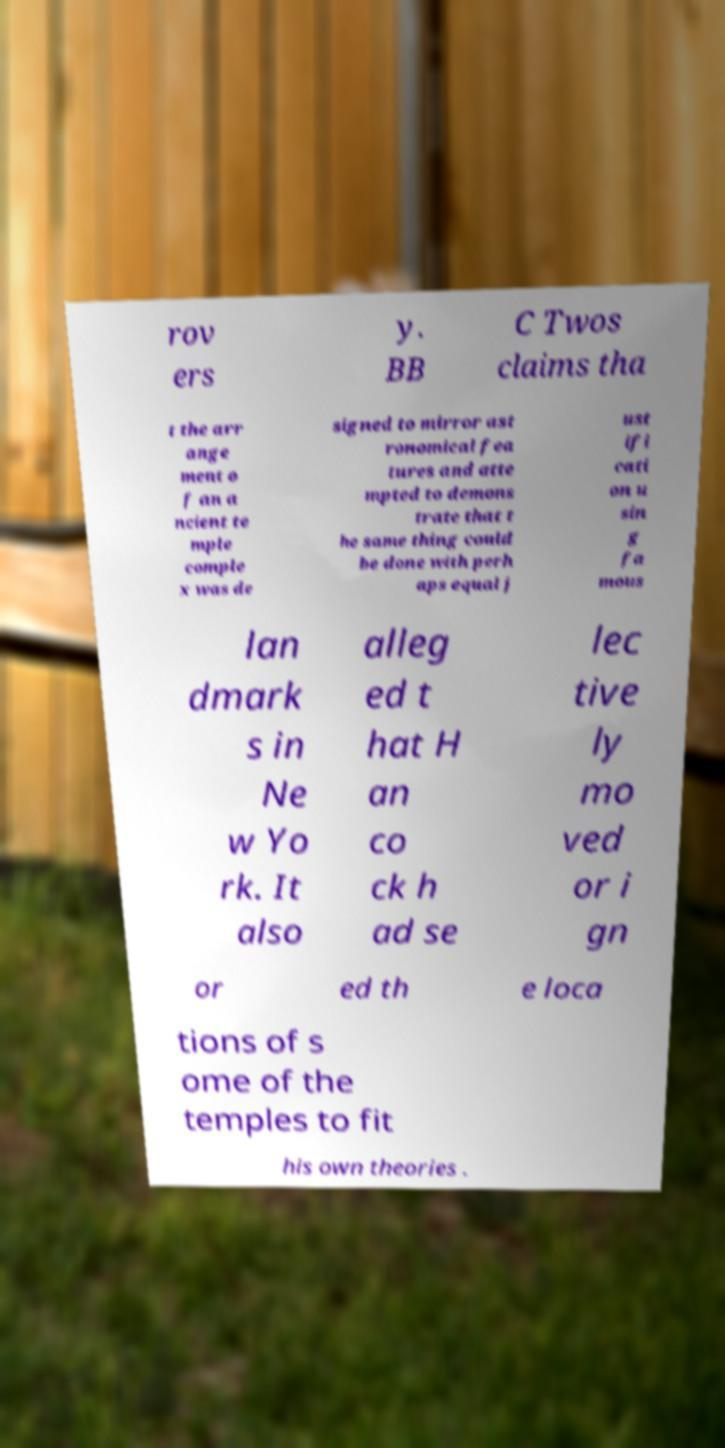What messages or text are displayed in this image? I need them in a readable, typed format. rov ers y. BB C Twos claims tha t the arr ange ment o f an a ncient te mple comple x was de signed to mirror ast ronomical fea tures and atte mpted to demons trate that t he same thing could be done with perh aps equal j ust ifi cati on u sin g fa mous lan dmark s in Ne w Yo rk. It also alleg ed t hat H an co ck h ad se lec tive ly mo ved or i gn or ed th e loca tions of s ome of the temples to fit his own theories . 